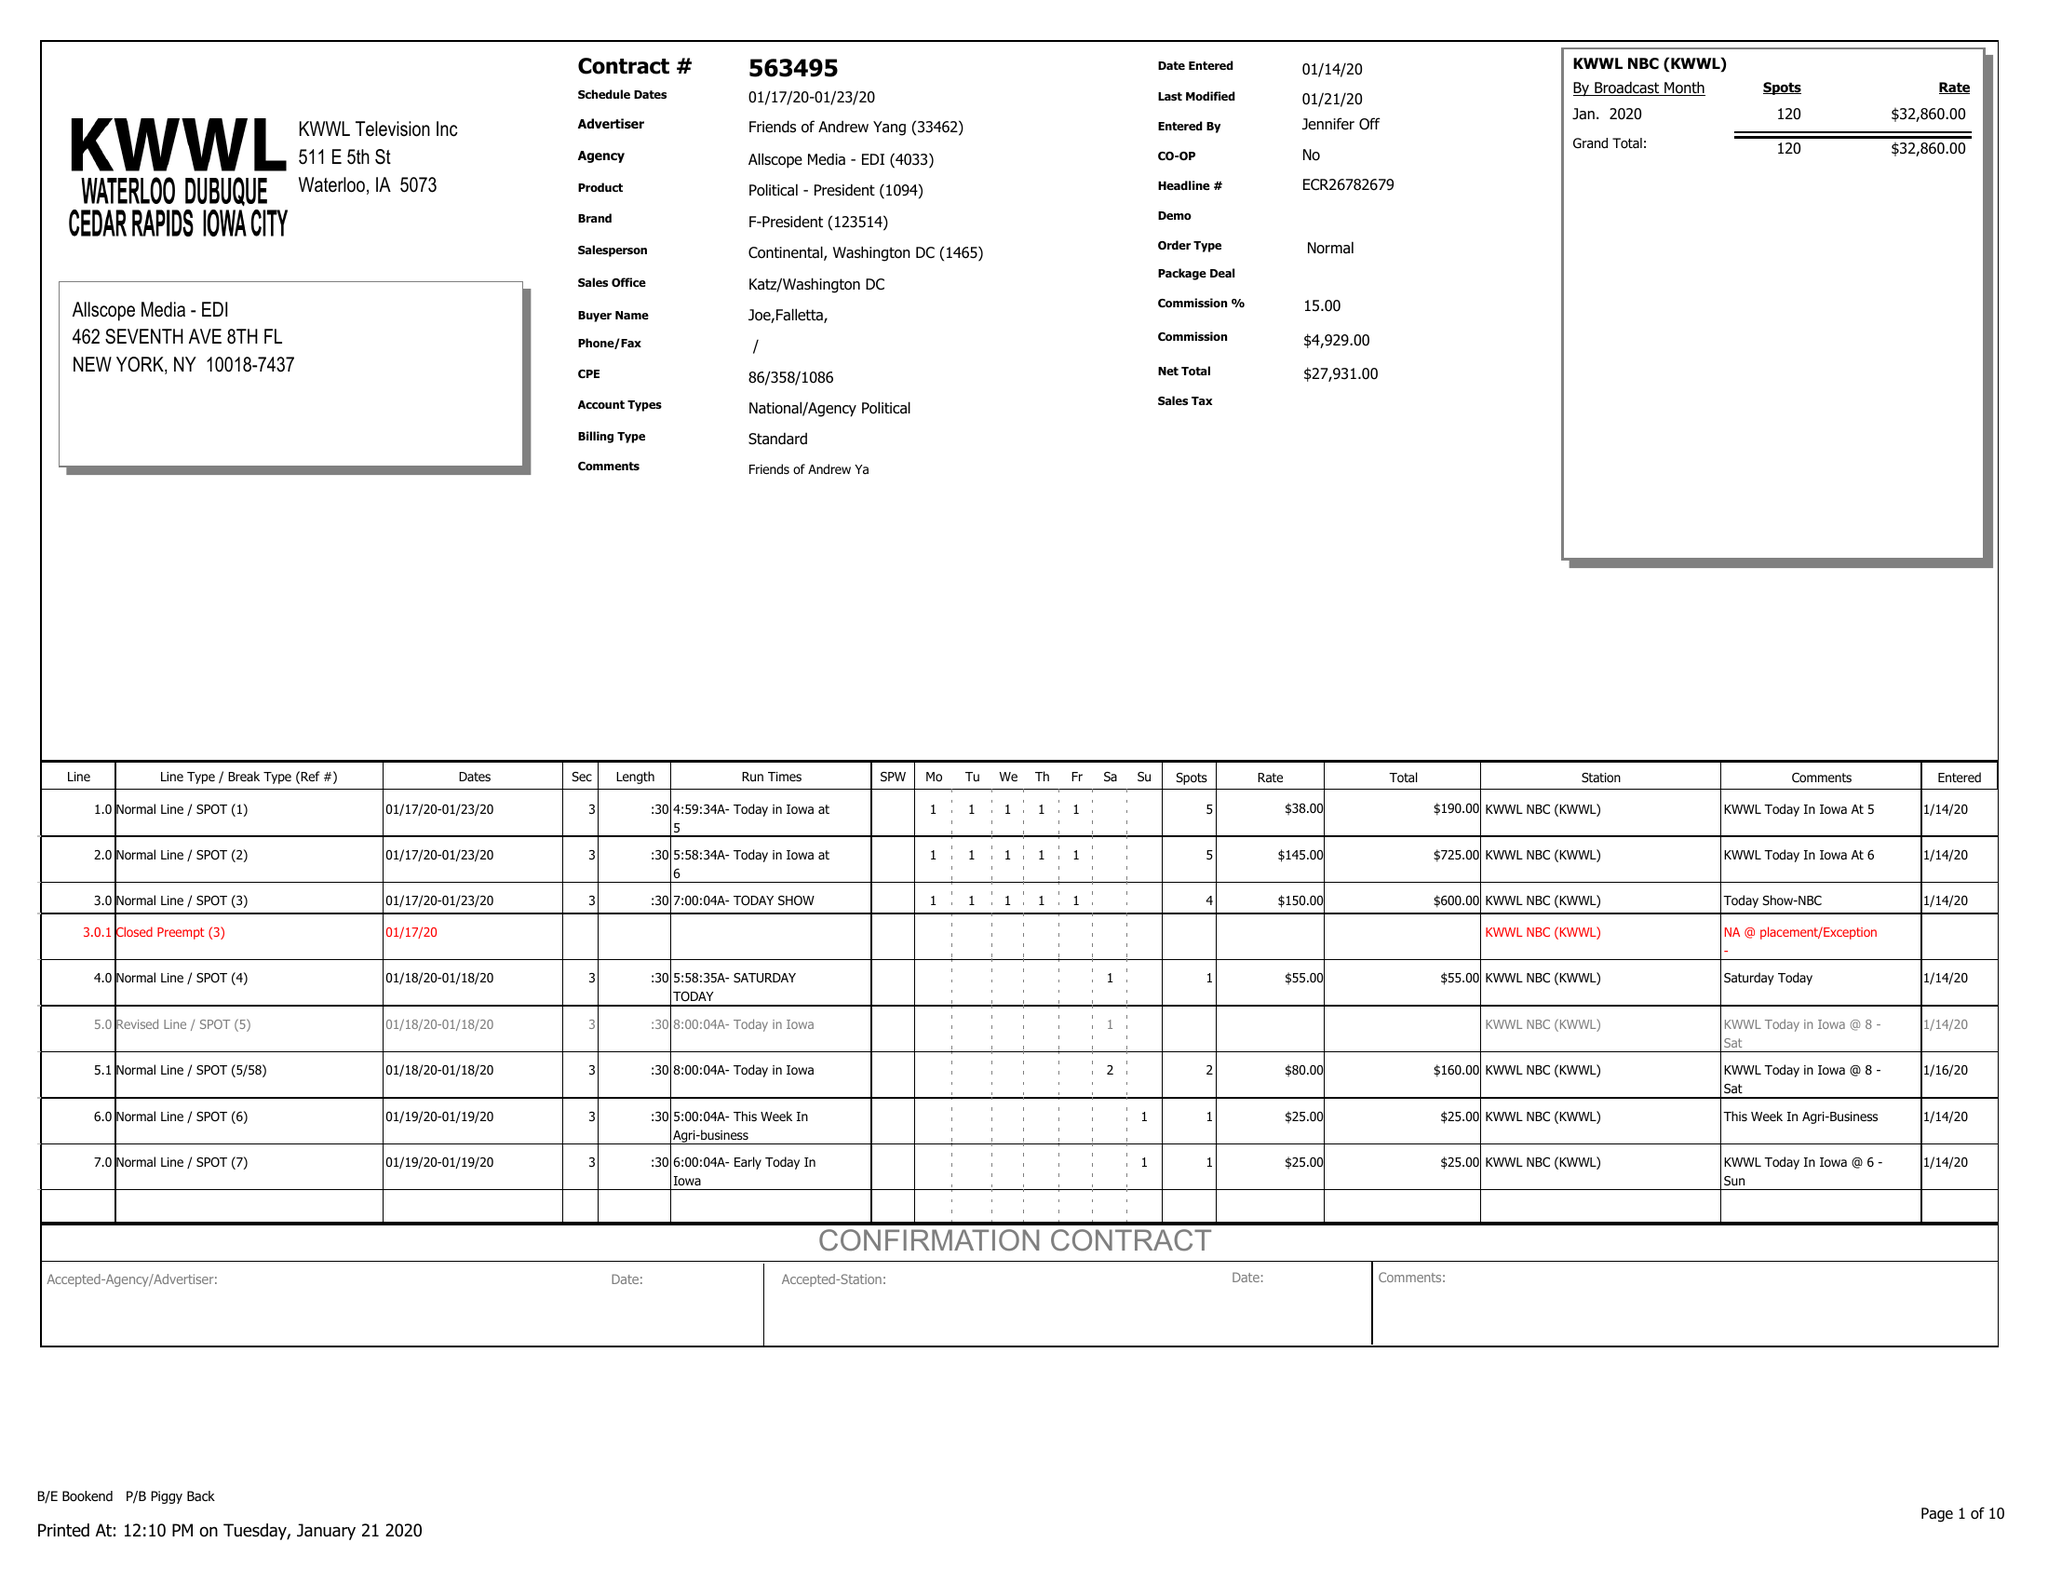What is the value for the contract_num?
Answer the question using a single word or phrase. 563495 